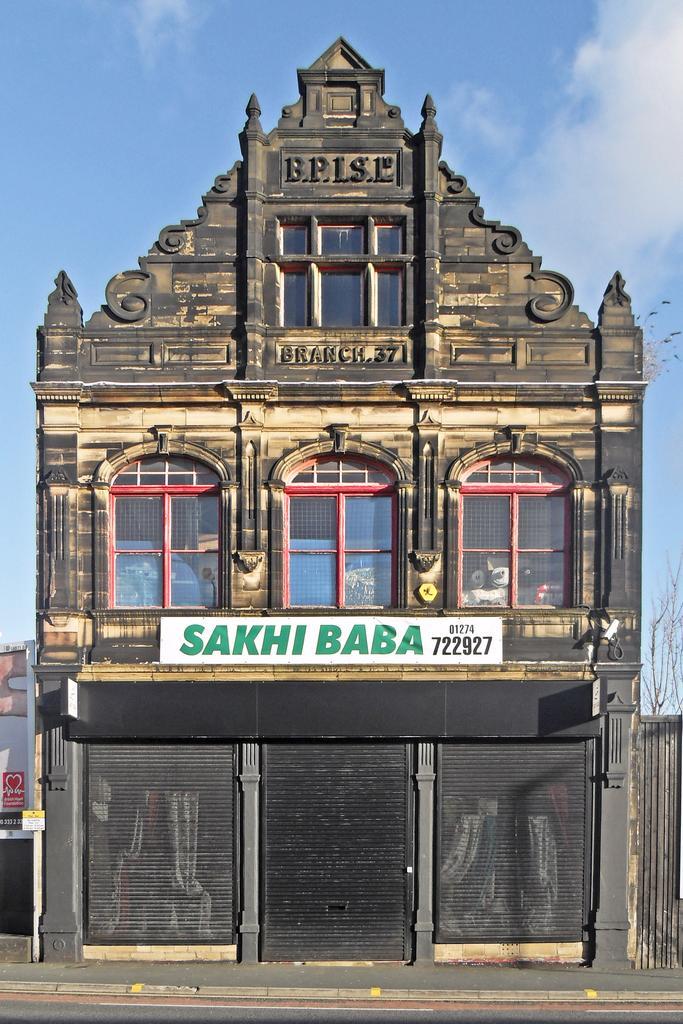In one or two sentences, can you explain what this image depicts? In this image I can see buildings, windows, board, shutters, fence, trees and the sky. This image is taken may be during a day. 